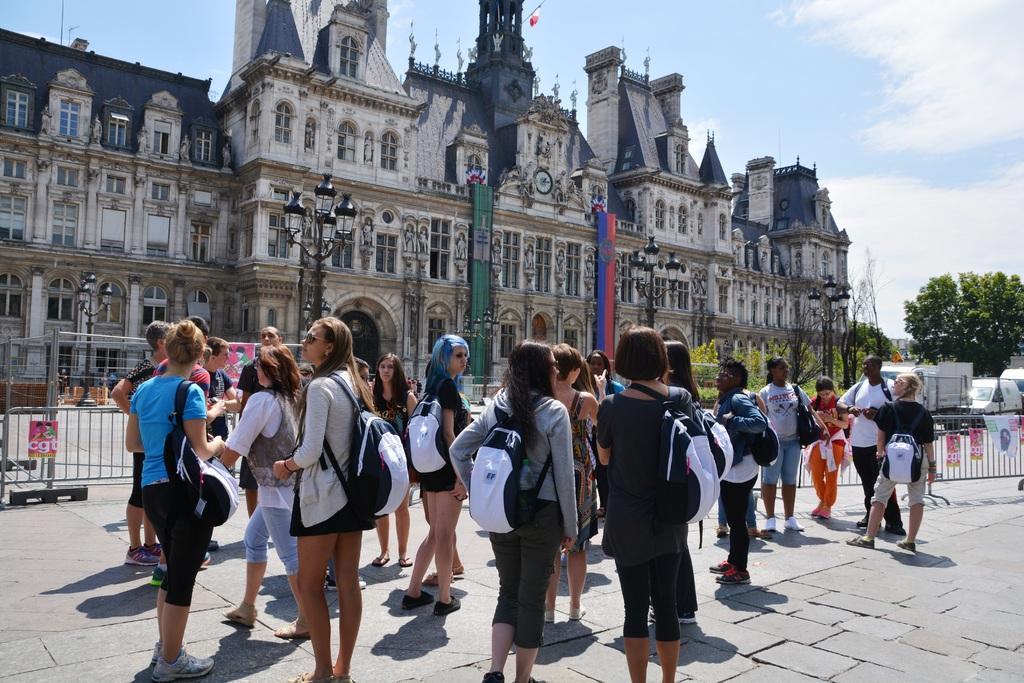Could you give a brief overview of what you see in this image? In the center of the image we can see some people are standing and wearing bags. In the background of the image we can see a building, windows, poles, lights, trees, barricades, vehicles, posters, road. At the bottom of the image we can see the pavement. At the top of the image we can see a flag and clouds in the sky. 